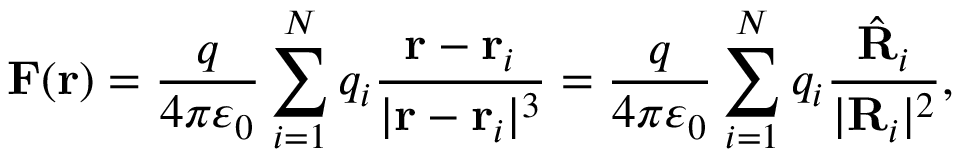<formula> <loc_0><loc_0><loc_500><loc_500>F ( r ) = { \frac { q } { 4 \pi \varepsilon _ { 0 } } } \sum _ { i = 1 } ^ { N } q _ { i } { \frac { r - r _ { i } } { | r - r _ { i } | ^ { 3 } } } = { \frac { q } { 4 \pi \varepsilon _ { 0 } } } \sum _ { i = 1 } ^ { N } q _ { i } { \frac { { \hat { R } } _ { i } } { | R _ { i } | ^ { 2 } } } ,</formula> 